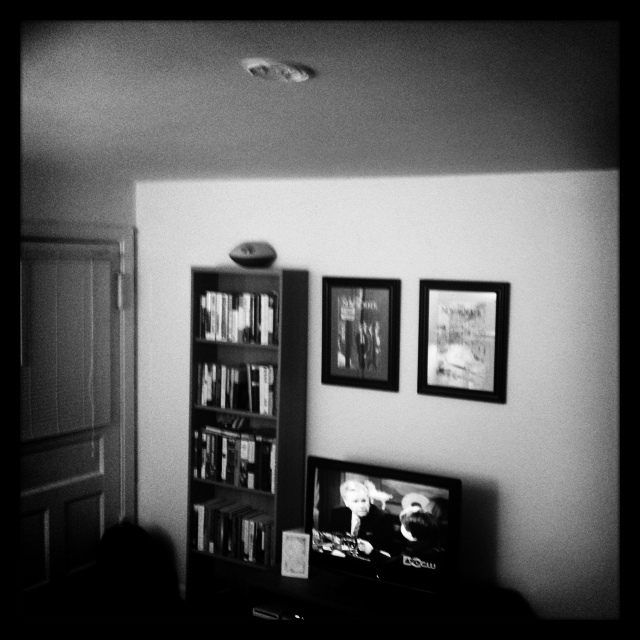<image>Who is the woman the picture on wall? It is unclear who the woman in the picture on the wall is. There is no woman in the image. Who is the woman the picture on wall? I don't know who the woman is in the picture on the wall. It can be any of the options mentioned. 